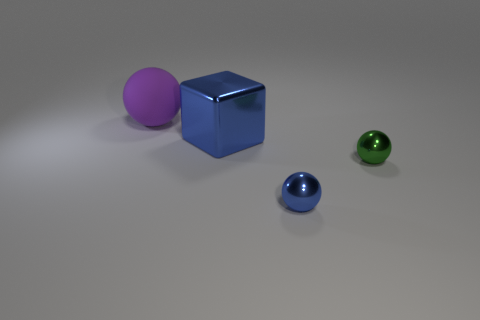Add 2 big yellow cubes. How many objects exist? 6 Subtract all cubes. How many objects are left? 3 Add 4 cyan matte cubes. How many cyan matte cubes exist? 4 Subtract 0 red balls. How many objects are left? 4 Subtract all metal balls. Subtract all large purple matte spheres. How many objects are left? 1 Add 4 purple matte spheres. How many purple matte spheres are left? 5 